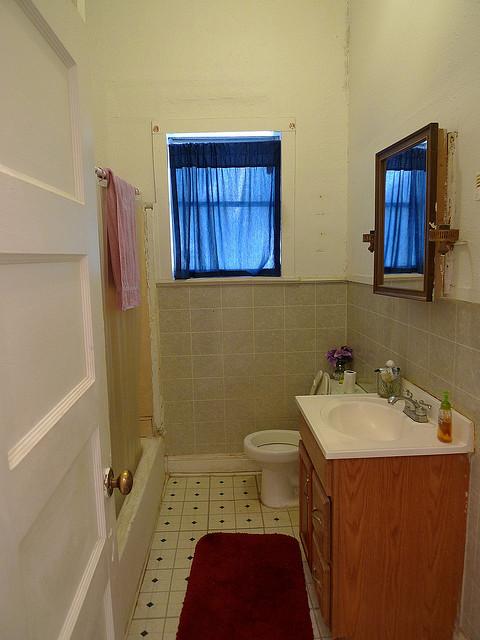Is this bathroom clean?
Give a very brief answer. Yes. Could you take a shower in this bath tub?
Answer briefly. Yes. IS there carpet on the floor?
Keep it brief. No. Is there a reflection in the mirror?
Be succinct. Yes. What color is the floor?
Be succinct. White. Is the toilet seat open?
Keep it brief. Yes. Is the toilet seat up or down?
Give a very brief answer. Up. 